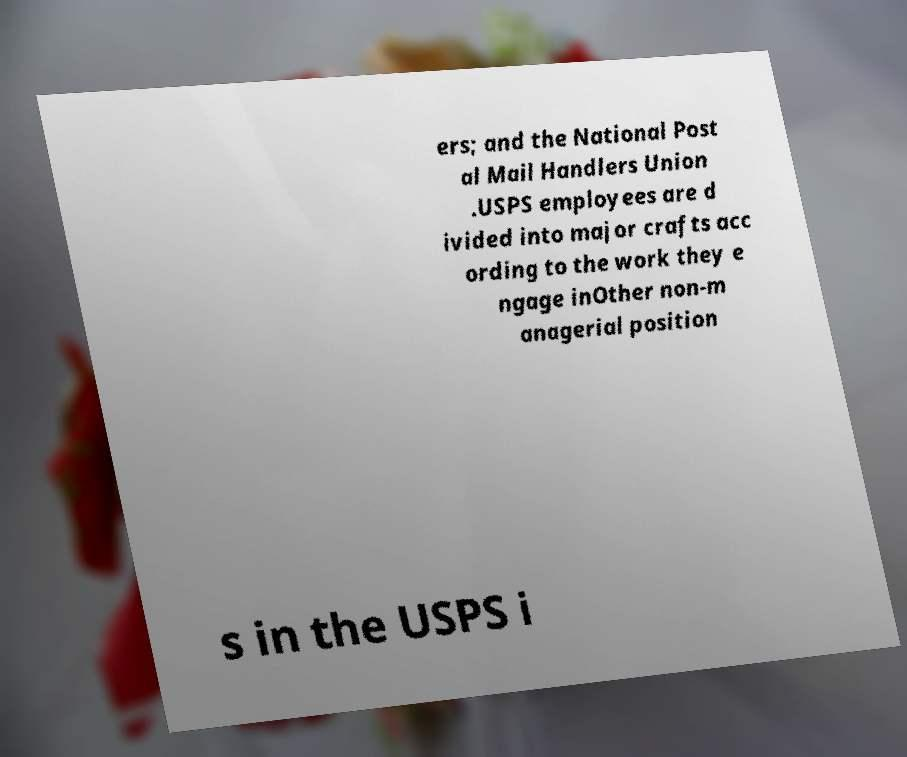For documentation purposes, I need the text within this image transcribed. Could you provide that? ers; and the National Post al Mail Handlers Union .USPS employees are d ivided into major crafts acc ording to the work they e ngage inOther non-m anagerial position s in the USPS i 